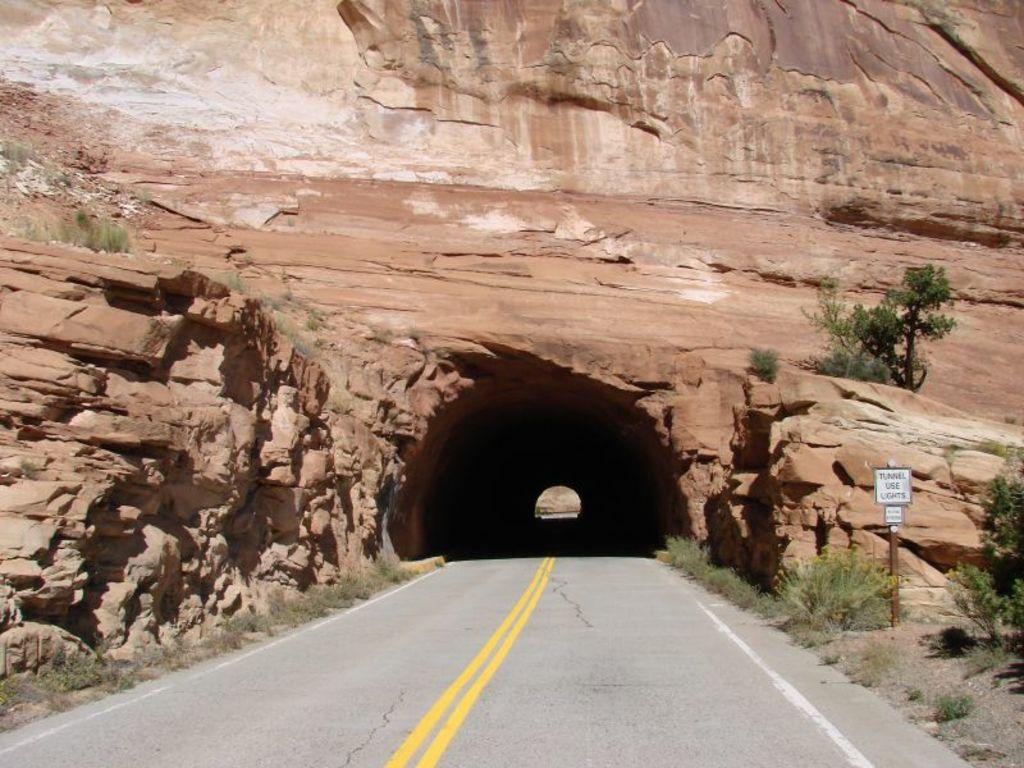What type of structure is present in the image? There is a tunnel in the image. What natural feature is visible in the image? There is a mountain in the image. What can be seen on the ground in the image? There is a road in the image. What is located on the right side of the image? There is a board and plants on the right side of the image. What is the title of the book that the maid is reading in the image? There is no book or maid present in the image. What is the fear that the mountain in the image represents? The image does not convey any fear or emotion associated with the mountain. 